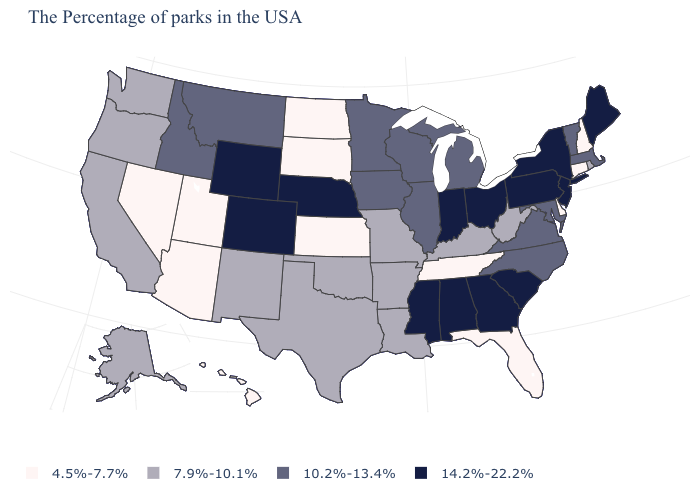Which states have the lowest value in the USA?
Concise answer only. New Hampshire, Connecticut, Delaware, Florida, Tennessee, Kansas, South Dakota, North Dakota, Utah, Arizona, Nevada, Hawaii. What is the value of Maryland?
Be succinct. 10.2%-13.4%. Which states have the lowest value in the USA?
Write a very short answer. New Hampshire, Connecticut, Delaware, Florida, Tennessee, Kansas, South Dakota, North Dakota, Utah, Arizona, Nevada, Hawaii. How many symbols are there in the legend?
Answer briefly. 4. What is the value of Nebraska?
Answer briefly. 14.2%-22.2%. What is the value of New Hampshire?
Answer briefly. 4.5%-7.7%. What is the value of Delaware?
Give a very brief answer. 4.5%-7.7%. What is the value of Mississippi?
Give a very brief answer. 14.2%-22.2%. Which states hav the highest value in the West?
Give a very brief answer. Wyoming, Colorado. Does the first symbol in the legend represent the smallest category?
Short answer required. Yes. Name the states that have a value in the range 10.2%-13.4%?
Answer briefly. Massachusetts, Vermont, Maryland, Virginia, North Carolina, Michigan, Wisconsin, Illinois, Minnesota, Iowa, Montana, Idaho. Does the map have missing data?
Quick response, please. No. What is the value of Colorado?
Be succinct. 14.2%-22.2%. Does Kentucky have the highest value in the South?
Concise answer only. No. Does Pennsylvania have the lowest value in the Northeast?
Keep it brief. No. 